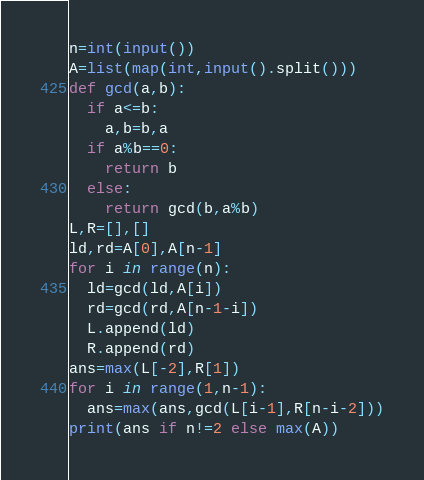Convert code to text. <code><loc_0><loc_0><loc_500><loc_500><_Python_>n=int(input())
A=list(map(int,input().split()))
def gcd(a,b):
  if a<=b:
    a,b=b,a
  if a%b==0:
    return b
  else:
    return gcd(b,a%b)
L,R=[],[]
ld,rd=A[0],A[n-1]
for i in range(n):
  ld=gcd(ld,A[i])
  rd=gcd(rd,A[n-1-i])
  L.append(ld)
  R.append(rd)
ans=max(L[-2],R[1])
for i in range(1,n-1):
  ans=max(ans,gcd(L[i-1],R[n-i-2]))
print(ans if n!=2 else max(A))</code> 